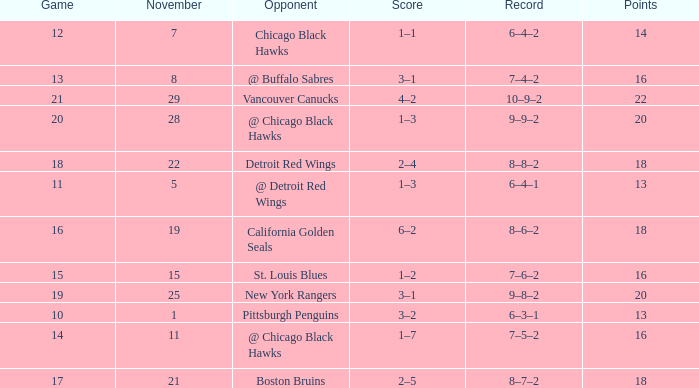What record has a november greater than 11, and st. louis blues as the opponent? 7–6–2. 